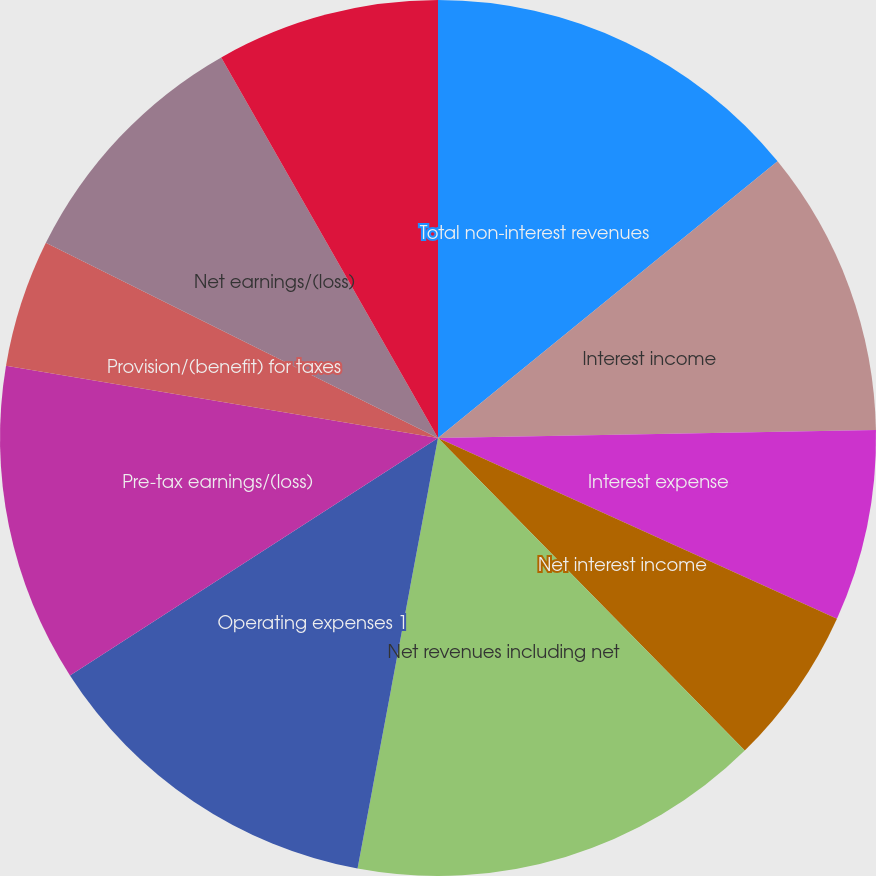Convert chart to OTSL. <chart><loc_0><loc_0><loc_500><loc_500><pie_chart><fcel>Total non-interest revenues<fcel>Interest income<fcel>Interest expense<fcel>Net interest income<fcel>Net revenues including net<fcel>Operating expenses 1<fcel>Pre-tax earnings/(loss)<fcel>Provision/(benefit) for taxes<fcel>Net earnings/(loss)<fcel>Preferred stock dividends<nl><fcel>14.12%<fcel>10.59%<fcel>7.06%<fcel>5.88%<fcel>15.29%<fcel>12.94%<fcel>11.76%<fcel>4.71%<fcel>9.41%<fcel>8.24%<nl></chart> 